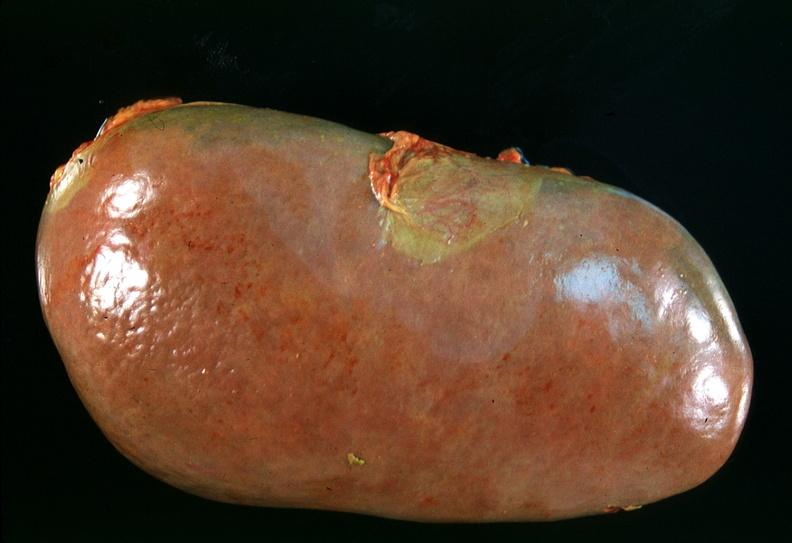does astrocytoma show spleen, chronic congestion due to portal hypertension from cirrhosis, hcv?
Answer the question using a single word or phrase. No 